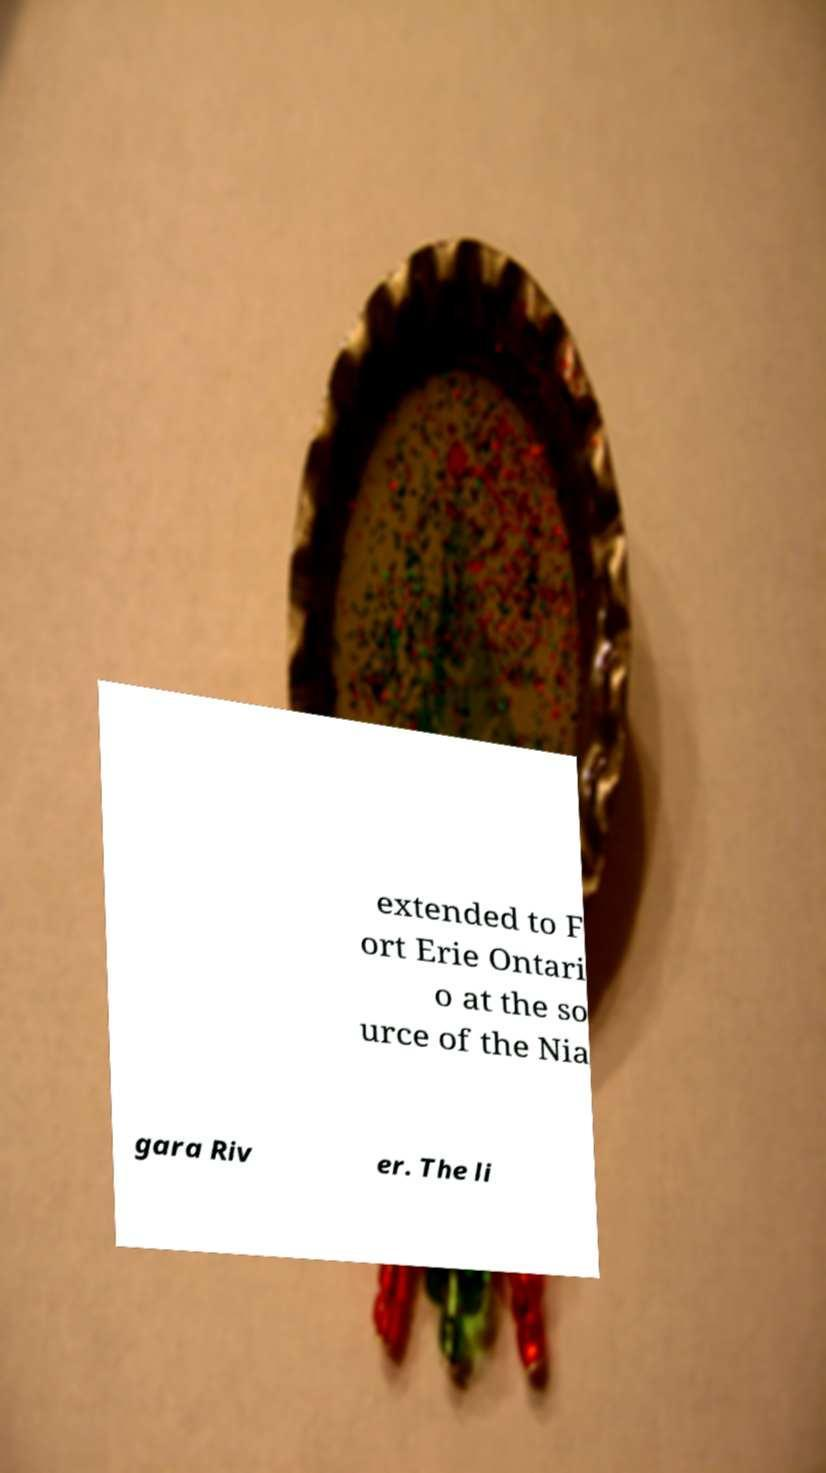What messages or text are displayed in this image? I need them in a readable, typed format. extended to F ort Erie Ontari o at the so urce of the Nia gara Riv er. The li 